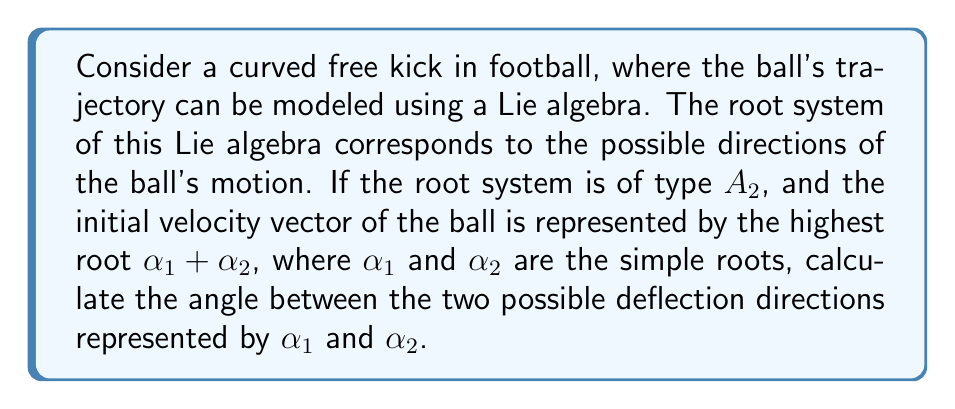Could you help me with this problem? To solve this problem, we need to follow these steps:

1) First, recall that in the $A_2$ root system, the simple roots $\alpha_1$ and $\alpha_2$ form an angle of 120°.

2) In the $A_2$ root system, the highest root $\alpha_1 + \alpha_2$ bisects the angle between $-\alpha_1$ and $-\alpha_2$.

3) Let's visualize this in the root diagram:

[asy]
unitsize(1cm);
draw((-1.5,-0.866) -- (1.5,0.866), arrow=Arrow(TeXHead));
draw((-1.5,0.866) -- (1.5,-0.866), arrow=Arrow(TeXHead));
draw((0,-1.732) -- (0,1.732), arrow=Arrow(TeXHead));
label("$\alpha_1$", (1.7,0.5));
label("$\alpha_2$", (-1.7,0.5));
label("$\alpha_1 + \alpha_2$", (0,1.9));
[/asy]

4) The angle between $\alpha_1$ and $\alpha_2$ is the same as the angle between $-\alpha_1$ and $-\alpha_2$, which is 120°.

5) Since $\alpha_1 + \alpha_2$ bisects this angle, the angle between $\alpha_1 + \alpha_2$ and either $\alpha_1$ or $\alpha_2$ is half of 120°, which is 60°.

6) Therefore, the angle between $\alpha_1$ and $\alpha_2$, which represent the two possible deflection directions, is:

   $$120° = 2 \pi / 3 \text{ radians}$$

This angle represents the maximum possible change in direction that the ball can undergo during its curved trajectory.
Answer: The angle between the two possible deflection directions represented by $\alpha_1$ and $\alpha_2$ is $120°$ or $2\pi/3$ radians. 